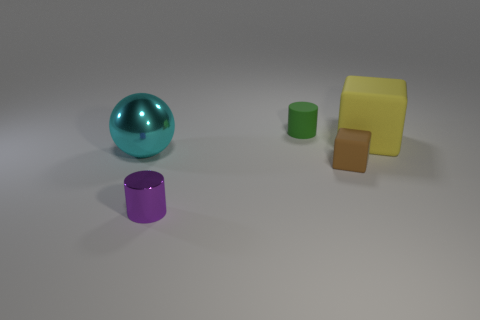Add 4 metal cylinders. How many objects exist? 9 Subtract all purple cylinders. How many cylinders are left? 1 Subtract all balls. How many objects are left? 4 Subtract all purple cylinders. How many yellow blocks are left? 1 Subtract all small brown objects. Subtract all purple metallic things. How many objects are left? 3 Add 2 big cyan metallic objects. How many big cyan metallic objects are left? 3 Add 2 large blue things. How many large blue things exist? 2 Subtract 0 red balls. How many objects are left? 5 Subtract all brown cylinders. Subtract all cyan balls. How many cylinders are left? 2 